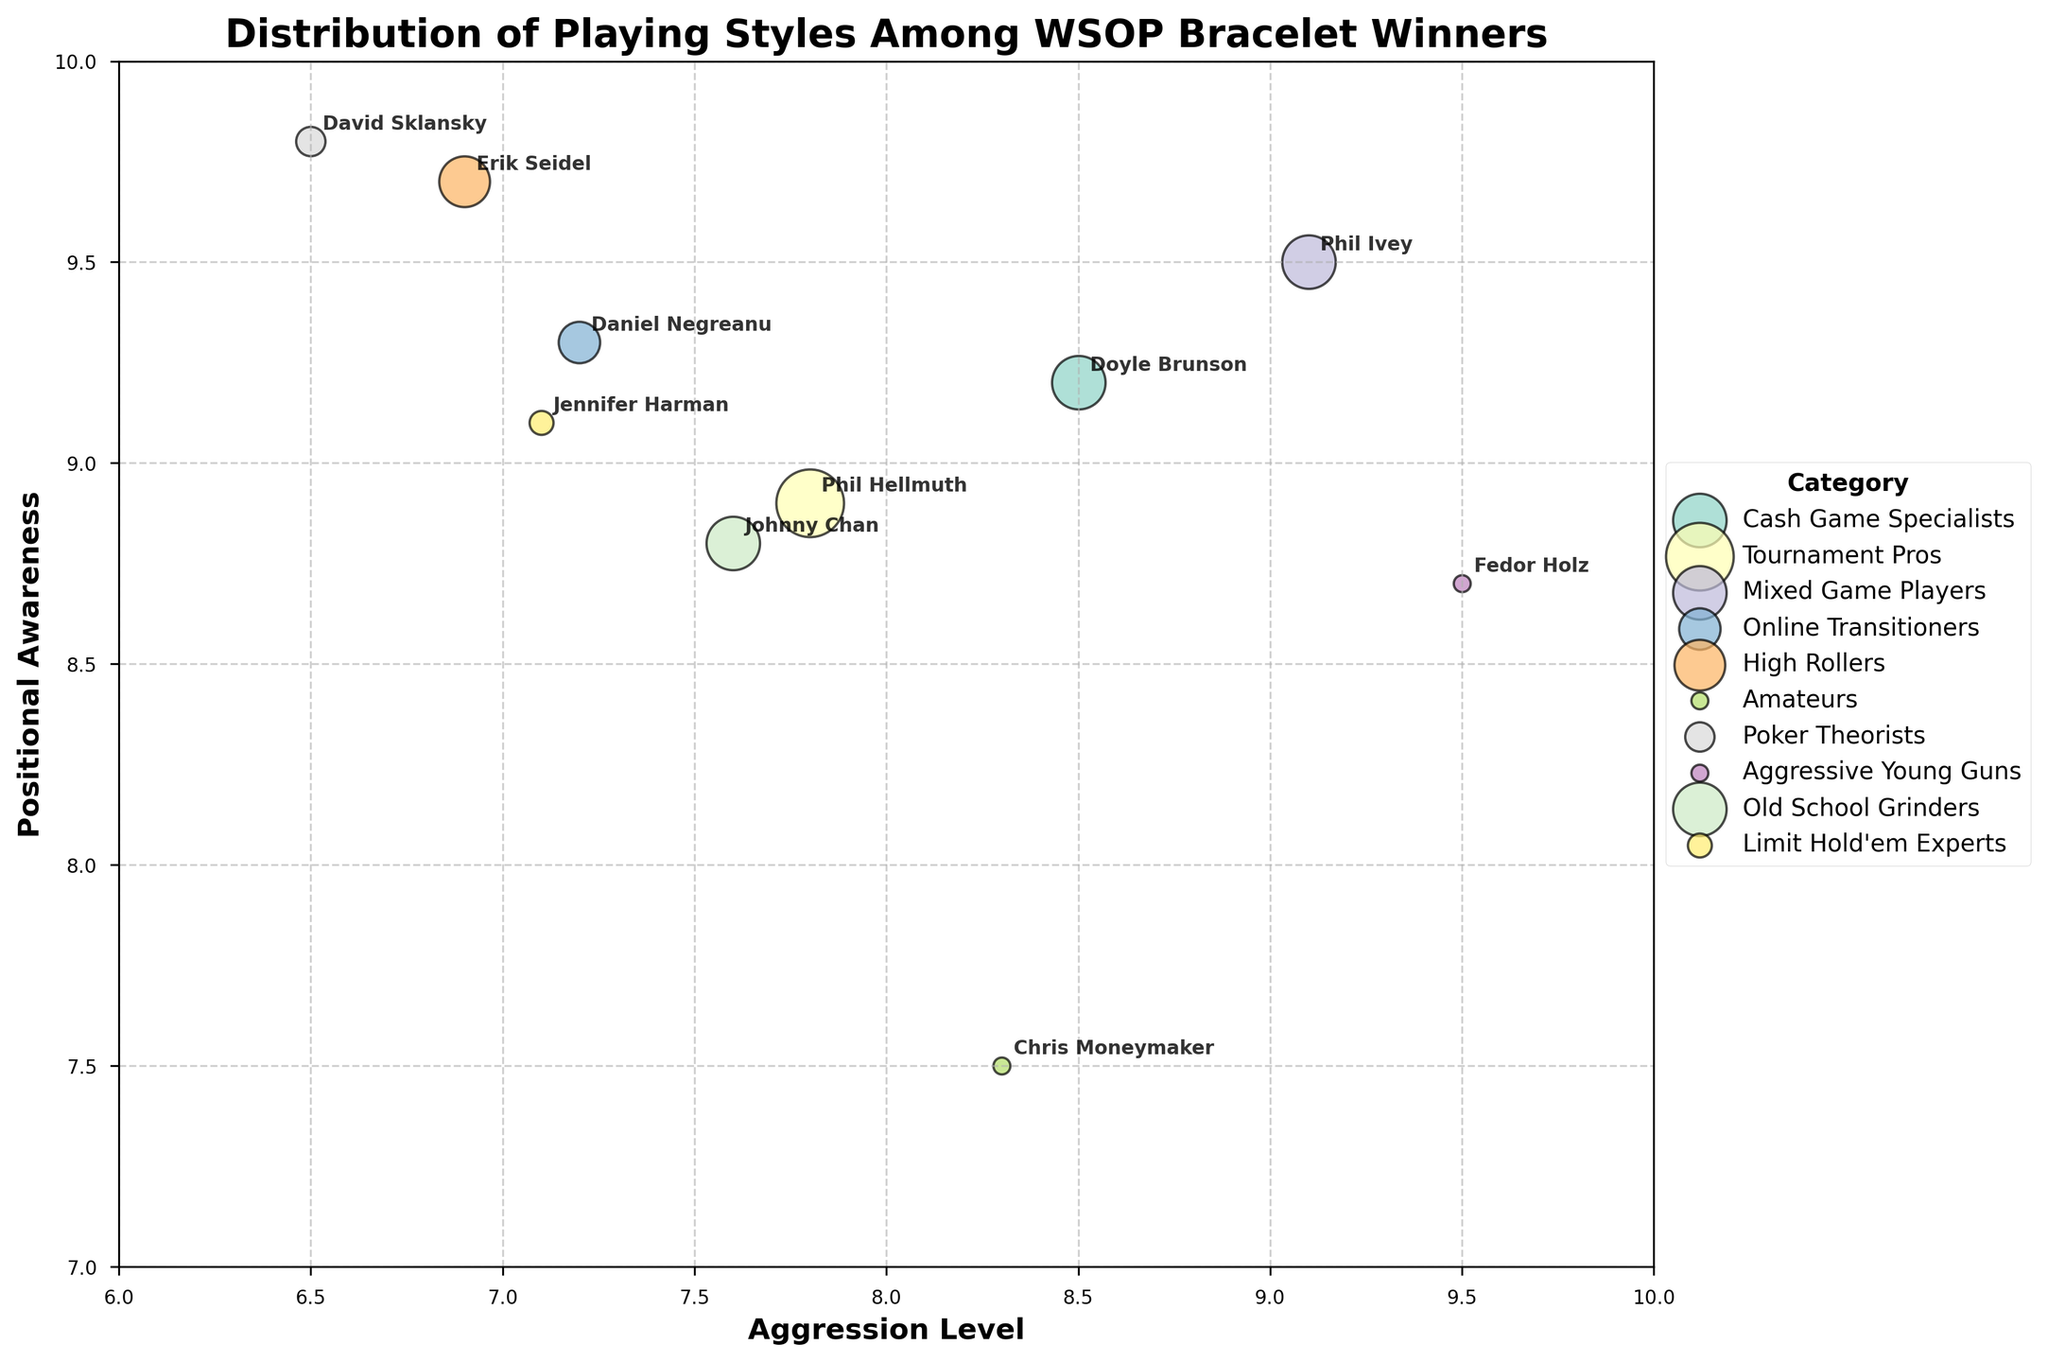what is the title of the figure? The title of the figure is displayed at the top and usually summarizes the content of the plot. It reads "Distribution of Playing Styles Among WSOP Bracelet Winners".
Answer: Distribution of Playing Styles Among WSOP Bracelet Winners How many categories of players are displayed in the figure? The legend on the right of the plot lists the different categories of players. By counting these entries, we can determine the number of categories.
Answer: 10 Who has the highest aggression level, and what is it? By examining the x-axis (Aggression Level) and identifying the player at the furthest right point, we see that Fedor Holz has the highest aggression level.
Answer: Fedor Holz, 9.5 What is the positional awareness level of Daniel Negreanu? Locate Daniel Negreanu's bubble and check the corresponding y-coordinate (Positional Awareness). It is at 9.3.
Answer: 9.3 Which player has won the most WSOP bracelets? The size of the bubbles represents the number of bracelets won. The largest bubble corresponds to Phil Hellmuth.
Answer: Phil Hellmuth Among the players, who has the lowest positional awareness? Comparing the y-values (Positional Awareness), Chris Moneymaker's bubble is the lowest at 7.5.
Answer: Chris Moneymaker How do Doyle Brunson’s and Johnny Chan's playing styles differ in terms of aggression level? Comparing the x-values of their bubbles, Doyle Brunson is at 8.5, while Johnny Chan is at 7.6, indicating that Doyle Brunson is more aggressive.
Answer: Doyle Brunson is more aggressive What is the average aggression level of the players who have won exactly 10 bracelets? Identify the players who have won 10 bracelets (Doyle Brunson, Phil Ivey, and Johnny Chan), then average their aggression levels: (8.5 + 9.1 + 7.6) / 3.
Answer: 8.4 What is the relationship between positional awareness and the number of bracelets for Phil Ivey and Erik Seidel? Phil Ivey has 9.5 positional awareness and 10 bracelets, while Erik Seidel has 9.7 positional awareness and 9 bracelets, showing that higher positional awareness does not necessarily correlate with more bracelets.
Answer: No clear correlation Which category tends to have higher positional awareness, Mixed Game Players or Poker Theorists? Compare the y-values for Mixed Game Players (Phil Ivey) and Poker Theorists (David Sklansky). David Sklansky has a higher positional awareness of 9.8 compared to Phil Ivey's 9.5.
Answer: Poker Theorists 